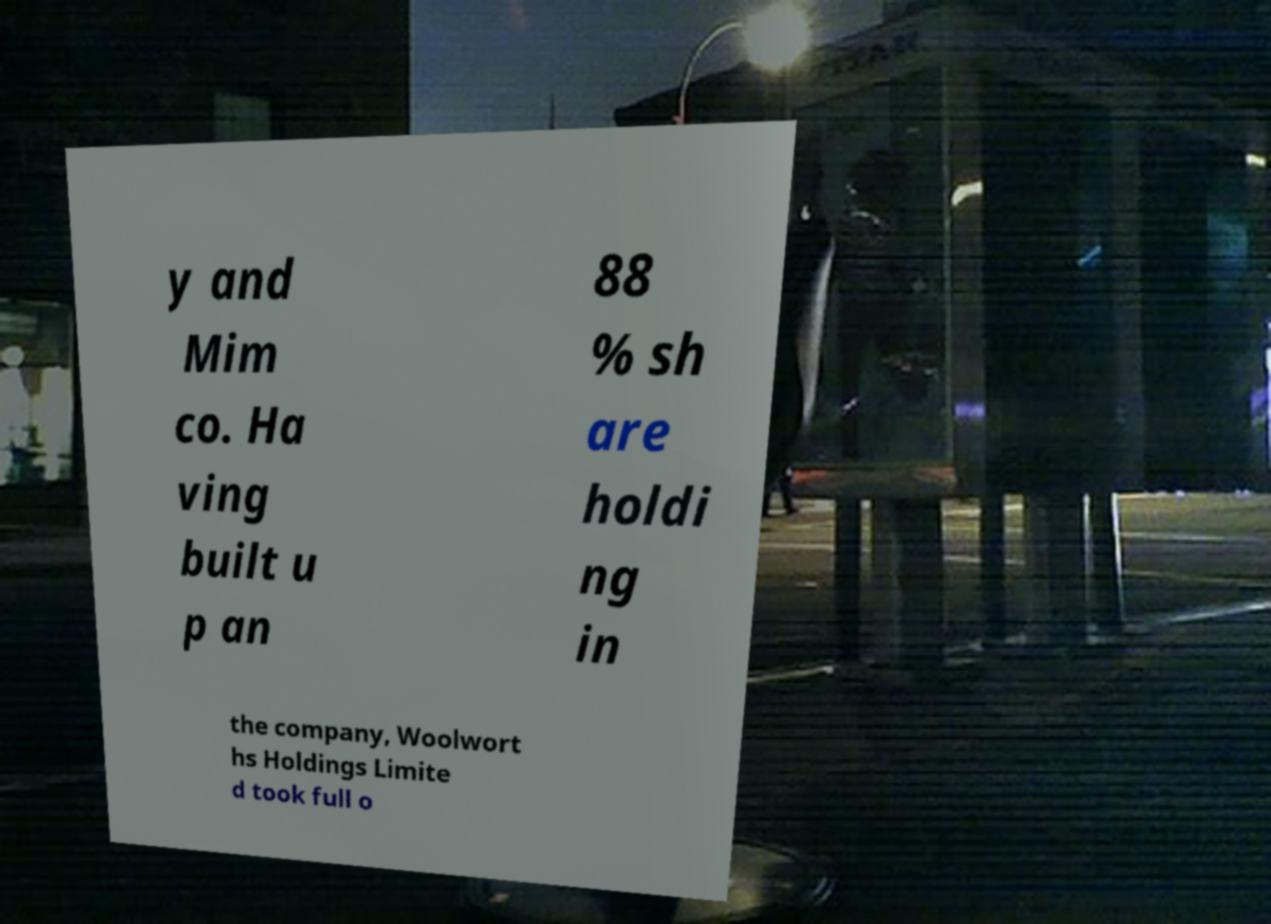I need the written content from this picture converted into text. Can you do that? y and Mim co. Ha ving built u p an 88 % sh are holdi ng in the company, Woolwort hs Holdings Limite d took full o 